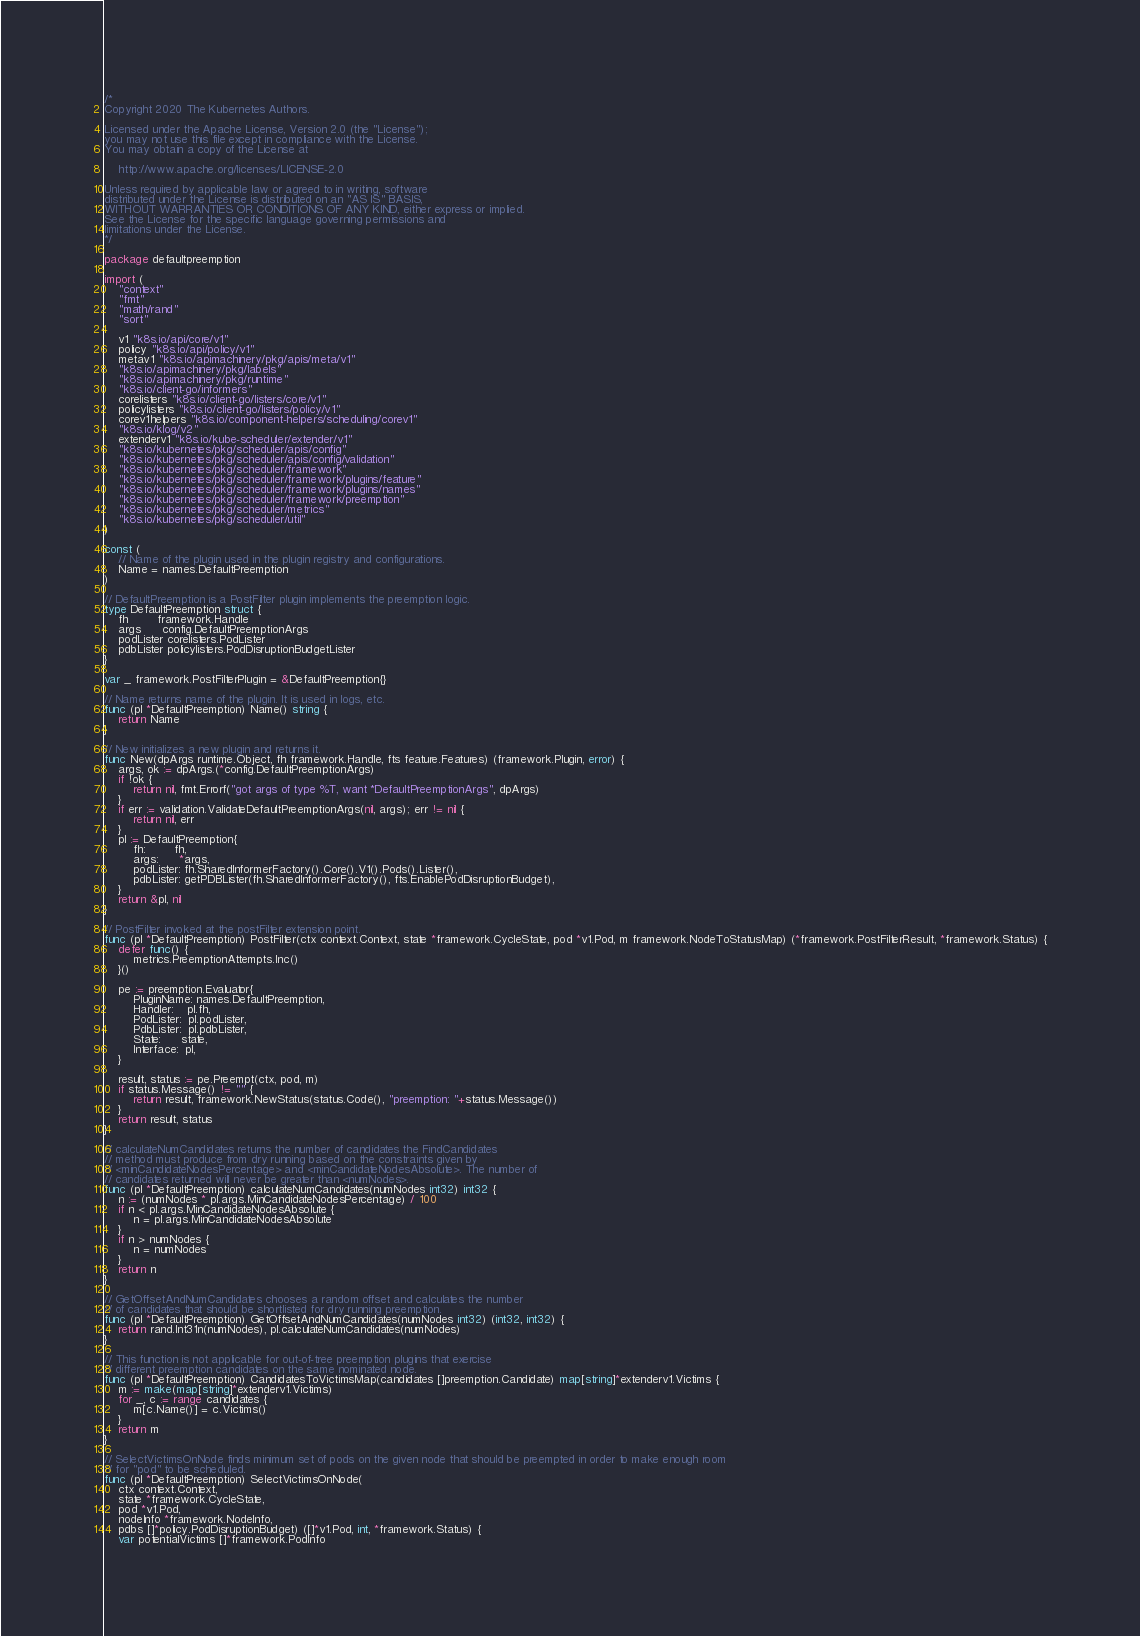<code> <loc_0><loc_0><loc_500><loc_500><_Go_>/*
Copyright 2020 The Kubernetes Authors.

Licensed under the Apache License, Version 2.0 (the "License");
you may not use this file except in compliance with the License.
You may obtain a copy of the License at

    http://www.apache.org/licenses/LICENSE-2.0

Unless required by applicable law or agreed to in writing, software
distributed under the License is distributed on an "AS IS" BASIS,
WITHOUT WARRANTIES OR CONDITIONS OF ANY KIND, either express or implied.
See the License for the specific language governing permissions and
limitations under the License.
*/

package defaultpreemption

import (
	"context"
	"fmt"
	"math/rand"
	"sort"

	v1 "k8s.io/api/core/v1"
	policy "k8s.io/api/policy/v1"
	metav1 "k8s.io/apimachinery/pkg/apis/meta/v1"
	"k8s.io/apimachinery/pkg/labels"
	"k8s.io/apimachinery/pkg/runtime"
	"k8s.io/client-go/informers"
	corelisters "k8s.io/client-go/listers/core/v1"
	policylisters "k8s.io/client-go/listers/policy/v1"
	corev1helpers "k8s.io/component-helpers/scheduling/corev1"
	"k8s.io/klog/v2"
	extenderv1 "k8s.io/kube-scheduler/extender/v1"
	"k8s.io/kubernetes/pkg/scheduler/apis/config"
	"k8s.io/kubernetes/pkg/scheduler/apis/config/validation"
	"k8s.io/kubernetes/pkg/scheduler/framework"
	"k8s.io/kubernetes/pkg/scheduler/framework/plugins/feature"
	"k8s.io/kubernetes/pkg/scheduler/framework/plugins/names"
	"k8s.io/kubernetes/pkg/scheduler/framework/preemption"
	"k8s.io/kubernetes/pkg/scheduler/metrics"
	"k8s.io/kubernetes/pkg/scheduler/util"
)

const (
	// Name of the plugin used in the plugin registry and configurations.
	Name = names.DefaultPreemption
)

// DefaultPreemption is a PostFilter plugin implements the preemption logic.
type DefaultPreemption struct {
	fh        framework.Handle
	args      config.DefaultPreemptionArgs
	podLister corelisters.PodLister
	pdbLister policylisters.PodDisruptionBudgetLister
}

var _ framework.PostFilterPlugin = &DefaultPreemption{}

// Name returns name of the plugin. It is used in logs, etc.
func (pl *DefaultPreemption) Name() string {
	return Name
}

// New initializes a new plugin and returns it.
func New(dpArgs runtime.Object, fh framework.Handle, fts feature.Features) (framework.Plugin, error) {
	args, ok := dpArgs.(*config.DefaultPreemptionArgs)
	if !ok {
		return nil, fmt.Errorf("got args of type %T, want *DefaultPreemptionArgs", dpArgs)
	}
	if err := validation.ValidateDefaultPreemptionArgs(nil, args); err != nil {
		return nil, err
	}
	pl := DefaultPreemption{
		fh:        fh,
		args:      *args,
		podLister: fh.SharedInformerFactory().Core().V1().Pods().Lister(),
		pdbLister: getPDBLister(fh.SharedInformerFactory(), fts.EnablePodDisruptionBudget),
	}
	return &pl, nil
}

// PostFilter invoked at the postFilter extension point.
func (pl *DefaultPreemption) PostFilter(ctx context.Context, state *framework.CycleState, pod *v1.Pod, m framework.NodeToStatusMap) (*framework.PostFilterResult, *framework.Status) {
	defer func() {
		metrics.PreemptionAttempts.Inc()
	}()

	pe := preemption.Evaluator{
		PluginName: names.DefaultPreemption,
		Handler:    pl.fh,
		PodLister:  pl.podLister,
		PdbLister:  pl.pdbLister,
		State:      state,
		Interface:  pl,
	}

	result, status := pe.Preempt(ctx, pod, m)
	if status.Message() != "" {
		return result, framework.NewStatus(status.Code(), "preemption: "+status.Message())
	}
	return result, status
}

// calculateNumCandidates returns the number of candidates the FindCandidates
// method must produce from dry running based on the constraints given by
// <minCandidateNodesPercentage> and <minCandidateNodesAbsolute>. The number of
// candidates returned will never be greater than <numNodes>.
func (pl *DefaultPreemption) calculateNumCandidates(numNodes int32) int32 {
	n := (numNodes * pl.args.MinCandidateNodesPercentage) / 100
	if n < pl.args.MinCandidateNodesAbsolute {
		n = pl.args.MinCandidateNodesAbsolute
	}
	if n > numNodes {
		n = numNodes
	}
	return n
}

// GetOffsetAndNumCandidates chooses a random offset and calculates the number
// of candidates that should be shortlisted for dry running preemption.
func (pl *DefaultPreemption) GetOffsetAndNumCandidates(numNodes int32) (int32, int32) {
	return rand.Int31n(numNodes), pl.calculateNumCandidates(numNodes)
}

// This function is not applicable for out-of-tree preemption plugins that exercise
// different preemption candidates on the same nominated node.
func (pl *DefaultPreemption) CandidatesToVictimsMap(candidates []preemption.Candidate) map[string]*extenderv1.Victims {
	m := make(map[string]*extenderv1.Victims)
	for _, c := range candidates {
		m[c.Name()] = c.Victims()
	}
	return m
}

// SelectVictimsOnNode finds minimum set of pods on the given node that should be preempted in order to make enough room
// for "pod" to be scheduled.
func (pl *DefaultPreemption) SelectVictimsOnNode(
	ctx context.Context,
	state *framework.CycleState,
	pod *v1.Pod,
	nodeInfo *framework.NodeInfo,
	pdbs []*policy.PodDisruptionBudget) ([]*v1.Pod, int, *framework.Status) {
	var potentialVictims []*framework.PodInfo</code> 